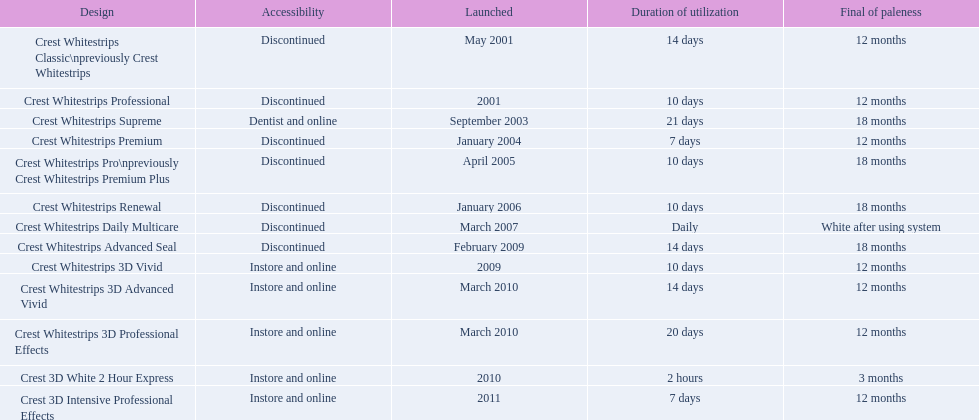What year did crest come out with crest white strips 3d vivid? 2009. Which crest product was also introduced he same year, but is now discontinued? Crest Whitestrips Advanced Seal. 